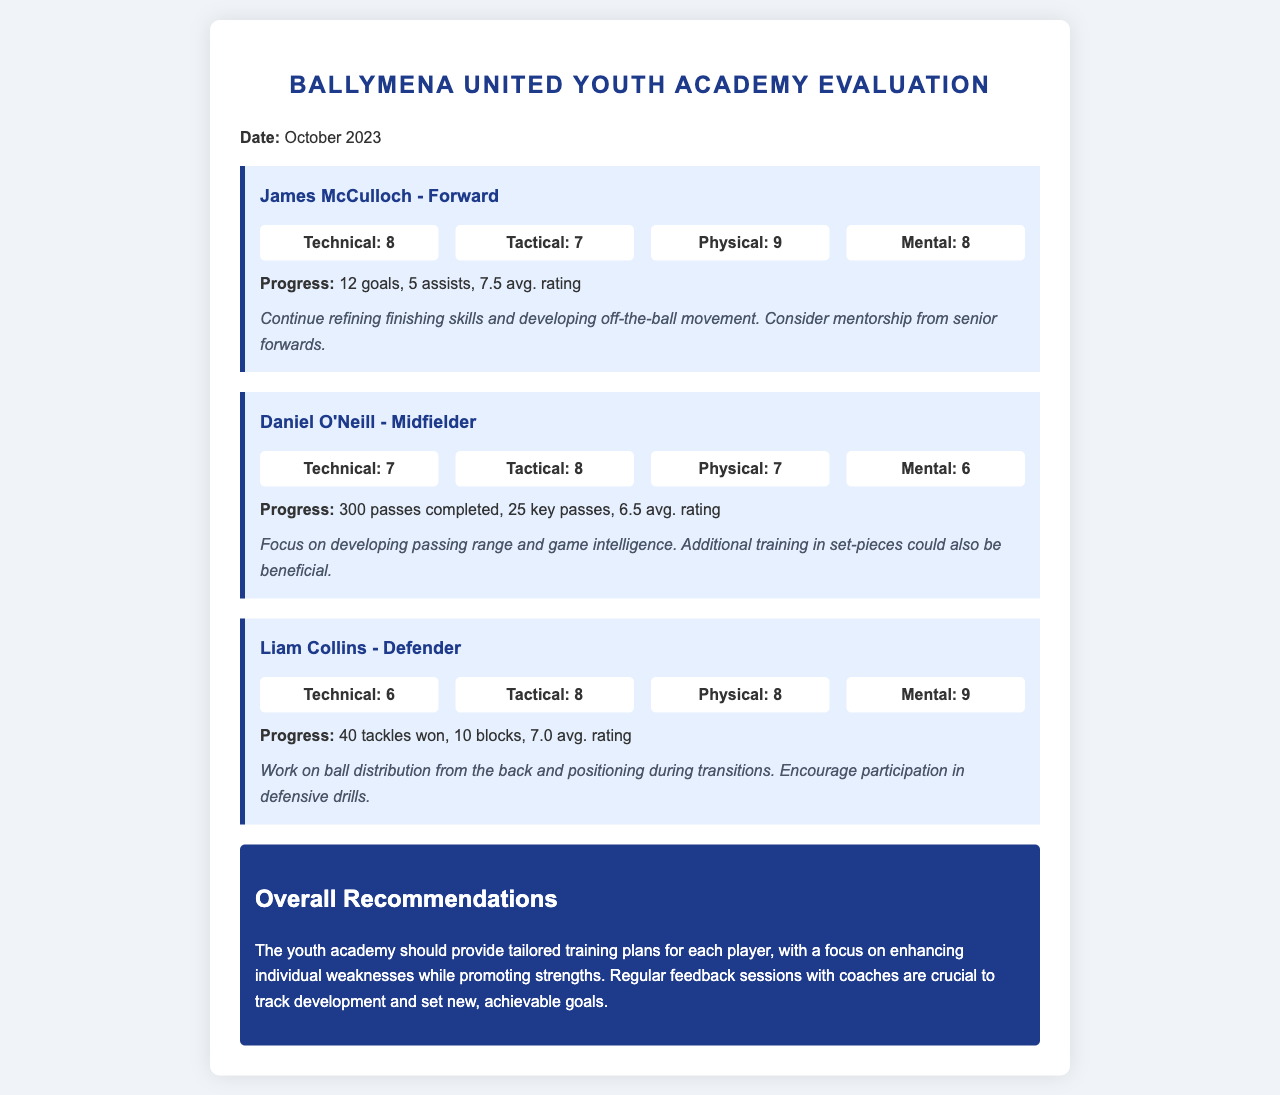What is the date of the evaluation? The date of the evaluation is mentioned at the beginning of the document.
Answer: October 2023 Who is the player evaluated as a forward? The player's position is indicated next to their name in their assessment section.
Answer: James McCulloch What is Liam Collins' mental rating? The mental rating is specified in the assessment section for each player.
Answer: 9 How many goals did James McCulloch score? The number of goals is provided in the progress section for each player, showing individual achievements.
Answer: 12 goals What is Daniel O'Neill's average rating? The average rating is part of the progress metrics included for each player in their evaluation.
Answer: 6.5 avg. rating Which player has the highest physical rating? The physical ratings of all players can be compared to find the highest value.
Answer: James McCulloch What recommendation is given for Daniel O'Neill? Specific recommendations for each player's development are provided in their respective sections.
Answer: Focus on developing passing range and game intelligence How many tackles did Liam Collins win? The progress section for each player details specific performance metrics, including tackles.
Answer: 40 tackles won What should the youth academy provide for each player? The overall recommendations in the document summarize the key suggestions for the academy's approach to player development.
Answer: Tailored training plans 